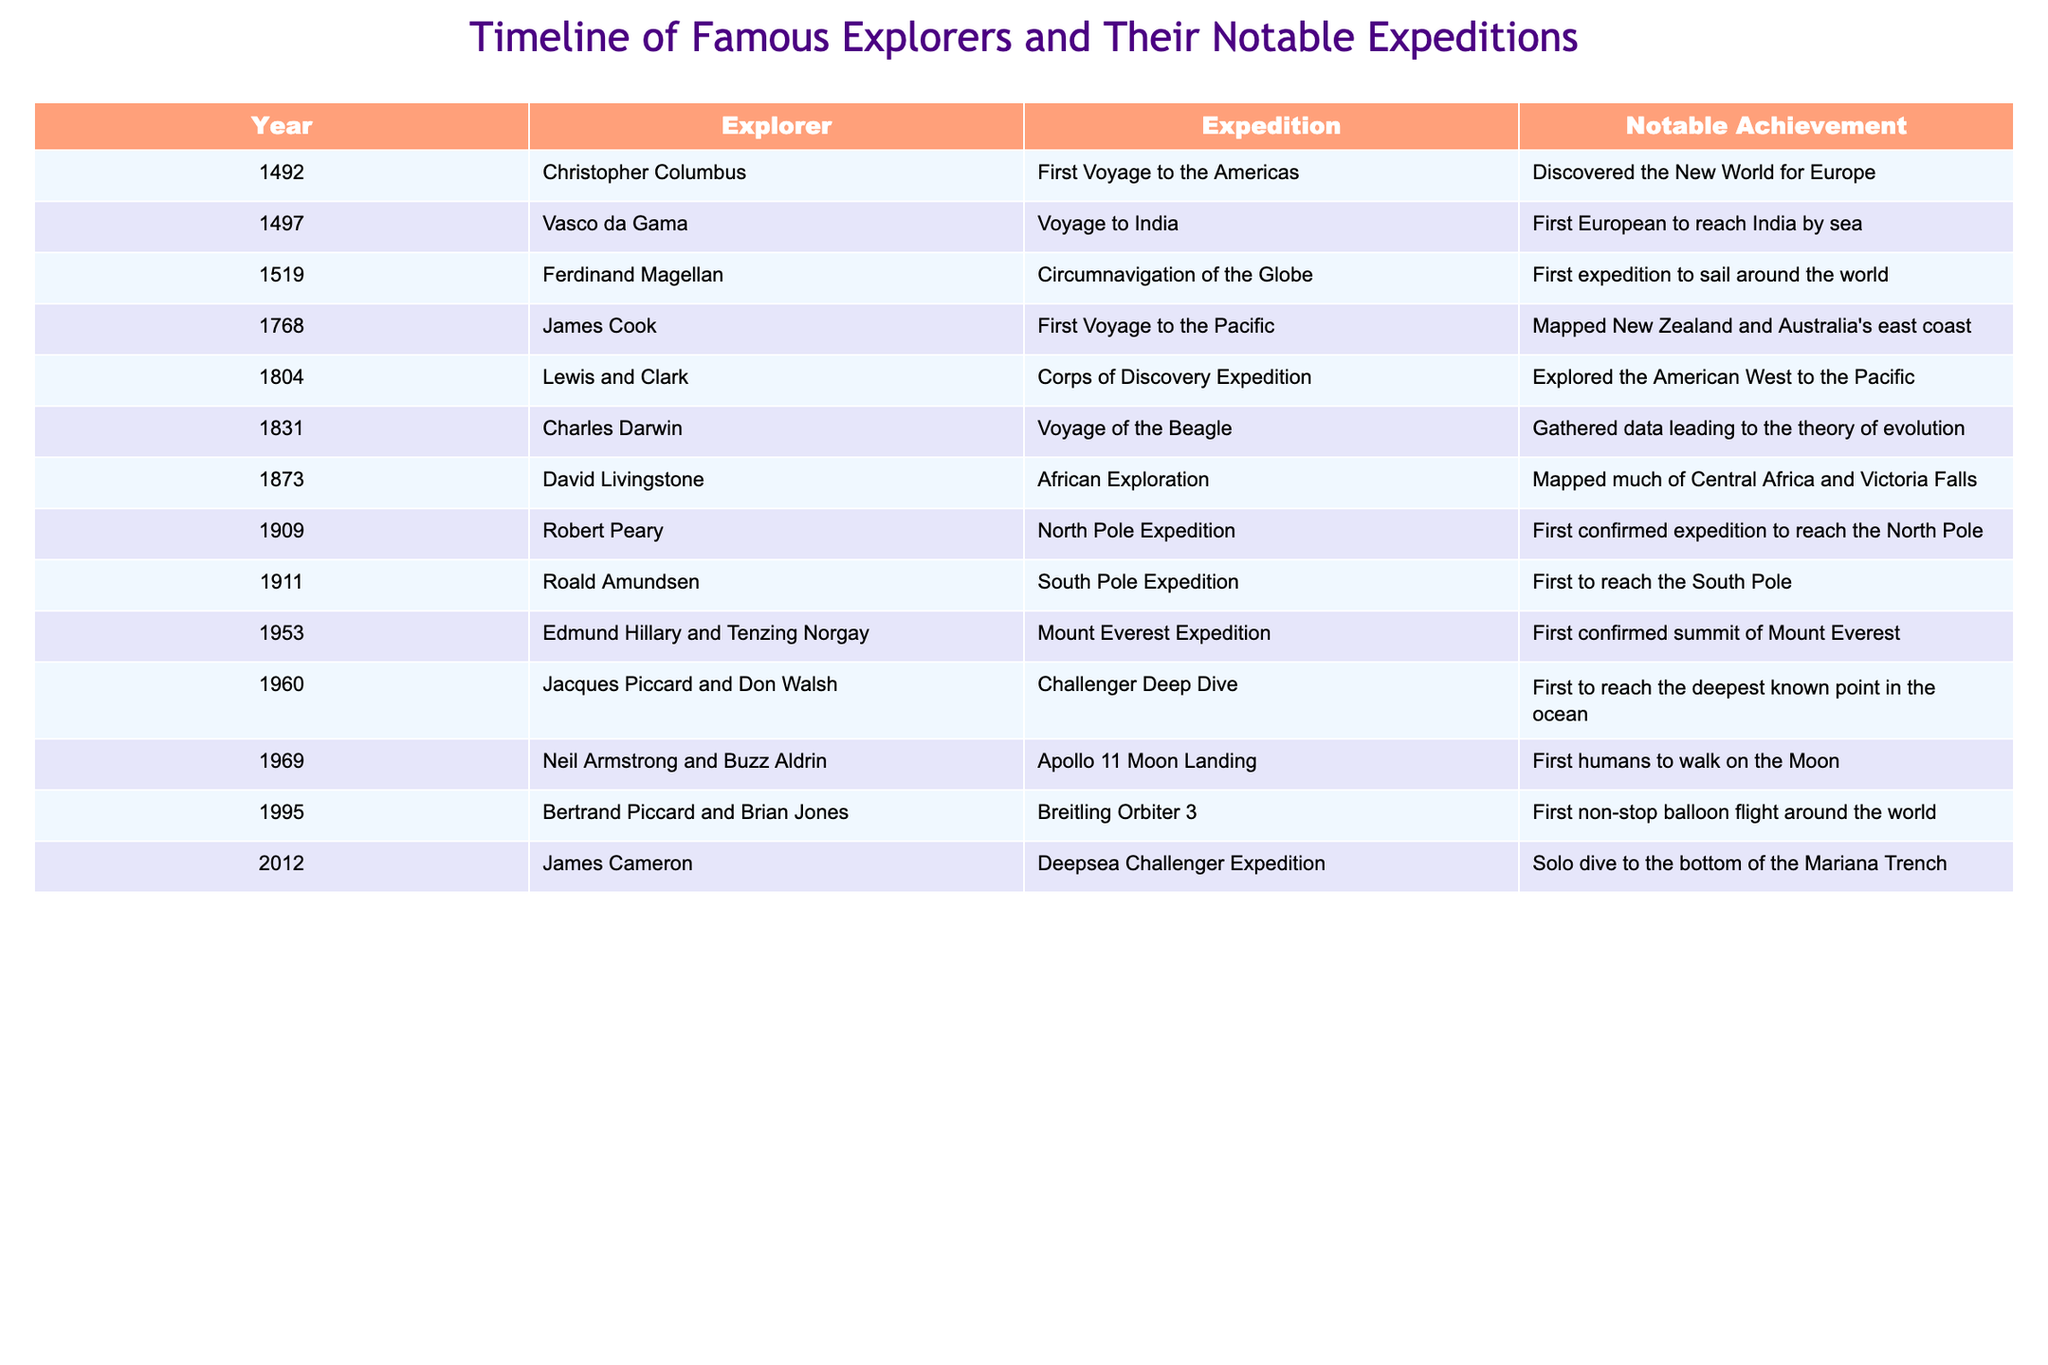What year did Christopher Columbus discover the New World for Europe? The table indicates that Christopher Columbus completed his first voyage to the Americas in 1492, which is when he discovered the New World for Europe.
Answer: 1492 Who was the first European to reach India by sea? According to the table, Vasco da Gama achieved this during his voyage to India in 1497.
Answer: Vasco da Gama How many years separated the first confirmed summit of Mount Everest from the first confirmed expedition to reach the North Pole? The table shows the first confirmed summit of Mount Everest occurred in 1953, and the first confirmed expedition to the North Pole took place in 1909. The difference in years is 1953 - 1909 = 44 years.
Answer: 44 years Was Charles Darwin's expedition before or after Lewis and Clark's expedition? By comparing the years, Charles Darwin's Voyage of the Beagle took place in 1831, while Lewis and Clark's Corps of Discovery Expedition occurred in 1804. Therefore, Darwin's expedition was after Lewis and Clark's.
Answer: After Which explorer's expedition had a notable achievement of gathering data leading to the theory of evolution? Referring to the table, it is clear that Charles Darwin's Voyage of the Beagle, in 1831, was significant for gathering data that eventually contributed to the theory of evolution.
Answer: Charles Darwin Which expedition occurred last: the Apollo 11 Moon Landing or the Challenger Deep Dive? The table indicates that the Apollo 11 Moon Landing took place in 1969, while the Challenger Deep Dive occurred in 1960. Since 1969 is later than 1960, the Apollo 11 Moon Landing occurred last.
Answer: Apollo 11 Moon Landing How many explorers' expeditions listed in the table reached a polar region? Looking at the table, we can identify that Robert Peary's North Pole Expedition and Roald Amundsen's South Pole Expedition both reached polar regions. Thus, there are two expeditions.
Answer: 2 What notable achievement is associated with Jacques Piccard and Don Walsh? According to the table, their notable achievement during the Challenger Deep Dive in 1960 was being the first to reach the deepest known point in the ocean.
Answer: First to reach the deepest known point in the ocean 